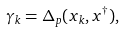<formula> <loc_0><loc_0><loc_500><loc_500>\gamma _ { k } = \Delta _ { p } ( x _ { k } , x ^ { \dag } ) ,</formula> 